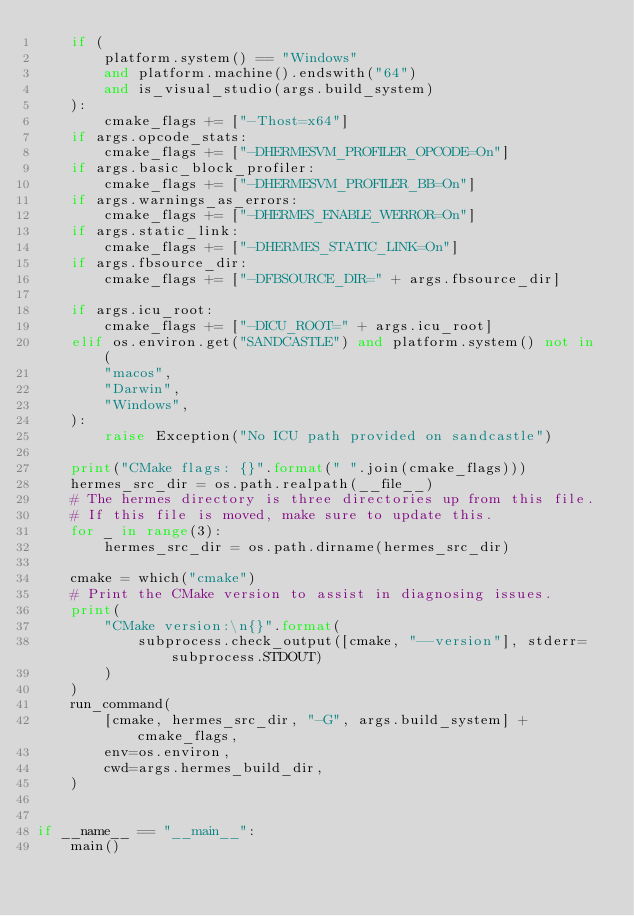Convert code to text. <code><loc_0><loc_0><loc_500><loc_500><_Python_>    if (
        platform.system() == "Windows"
        and platform.machine().endswith("64")
        and is_visual_studio(args.build_system)
    ):
        cmake_flags += ["-Thost=x64"]
    if args.opcode_stats:
        cmake_flags += ["-DHERMESVM_PROFILER_OPCODE=On"]
    if args.basic_block_profiler:
        cmake_flags += ["-DHERMESVM_PROFILER_BB=On"]
    if args.warnings_as_errors:
        cmake_flags += ["-DHERMES_ENABLE_WERROR=On"]
    if args.static_link:
        cmake_flags += ["-DHERMES_STATIC_LINK=On"]
    if args.fbsource_dir:
        cmake_flags += ["-DFBSOURCE_DIR=" + args.fbsource_dir]

    if args.icu_root:
        cmake_flags += ["-DICU_ROOT=" + args.icu_root]
    elif os.environ.get("SANDCASTLE") and platform.system() not in (
        "macos",
        "Darwin",
        "Windows",
    ):
        raise Exception("No ICU path provided on sandcastle")

    print("CMake flags: {}".format(" ".join(cmake_flags)))
    hermes_src_dir = os.path.realpath(__file__)
    # The hermes directory is three directories up from this file.
    # If this file is moved, make sure to update this.
    for _ in range(3):
        hermes_src_dir = os.path.dirname(hermes_src_dir)

    cmake = which("cmake")
    # Print the CMake version to assist in diagnosing issues.
    print(
        "CMake version:\n{}".format(
            subprocess.check_output([cmake, "--version"], stderr=subprocess.STDOUT)
        )
    )
    run_command(
        [cmake, hermes_src_dir, "-G", args.build_system] + cmake_flags,
        env=os.environ,
        cwd=args.hermes_build_dir,
    )


if __name__ == "__main__":
    main()
</code> 